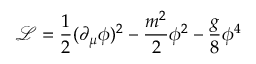Convert formula to latex. <formula><loc_0><loc_0><loc_500><loc_500>\mathcal { L } = \frac { 1 } { 2 } ( \partial _ { \mu } \phi ) ^ { 2 } - \frac { m ^ { 2 } } { 2 } \phi ^ { 2 } - \frac { g } { 8 } \phi ^ { 4 }</formula> 